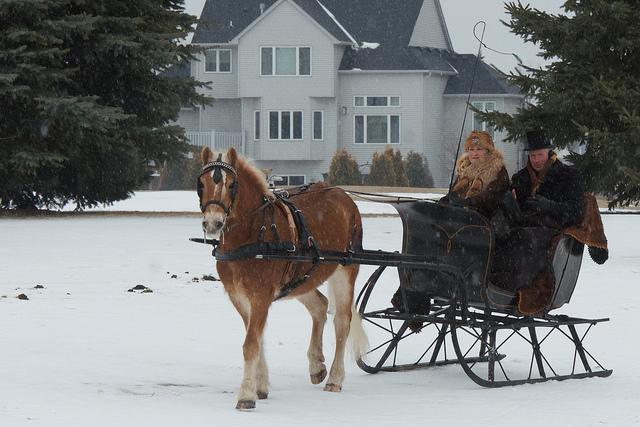How many people is in the sled?
Give a very brief answer. 2. How many people are visible?
Give a very brief answer. 2. 